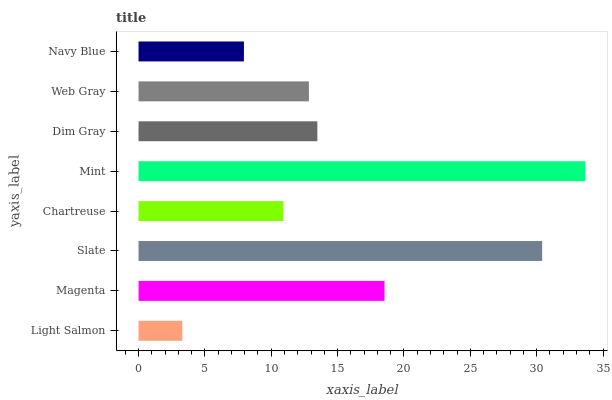Is Light Salmon the minimum?
Answer yes or no. Yes. Is Mint the maximum?
Answer yes or no. Yes. Is Magenta the minimum?
Answer yes or no. No. Is Magenta the maximum?
Answer yes or no. No. Is Magenta greater than Light Salmon?
Answer yes or no. Yes. Is Light Salmon less than Magenta?
Answer yes or no. Yes. Is Light Salmon greater than Magenta?
Answer yes or no. No. Is Magenta less than Light Salmon?
Answer yes or no. No. Is Dim Gray the high median?
Answer yes or no. Yes. Is Web Gray the low median?
Answer yes or no. Yes. Is Chartreuse the high median?
Answer yes or no. No. Is Mint the low median?
Answer yes or no. No. 